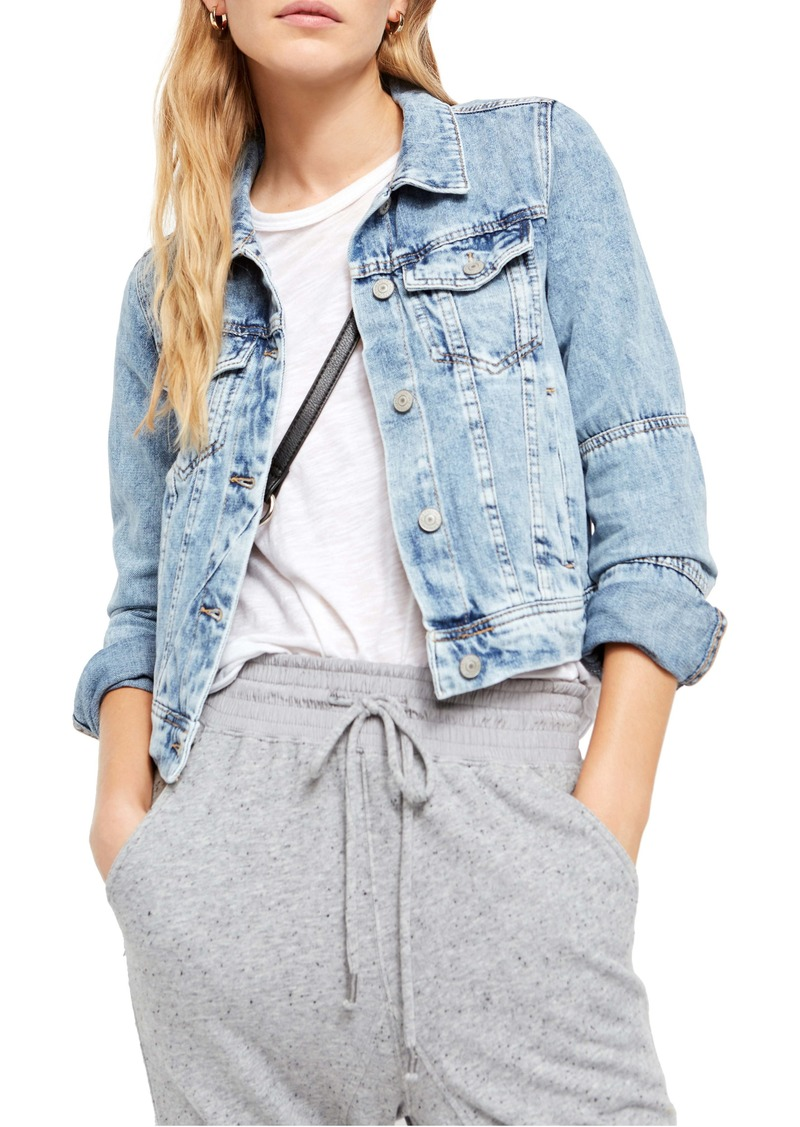What can you tell about the occasion or setting this outfit might be suitable for? The outfit shown appears highly versatile and could be suitable for a range of casual settings such as a day out with friends, a casual date, or a shopping trip. The denim jacket adds a layer that is not only stylish but also practical for variable weather, while the grey sweatpants suggest a comfort-first approach, ideal for activities that require a lot of movement or relaxation. 